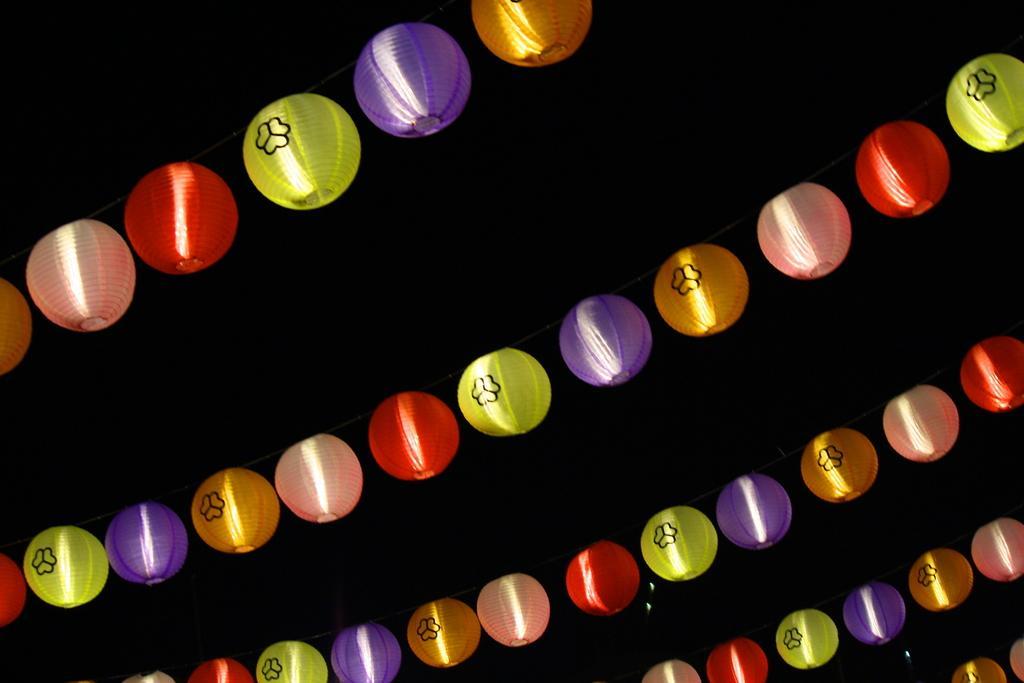How would you summarize this image in a sentence or two? In this image, there are some different, different color ball lights hanging on the ropes. 